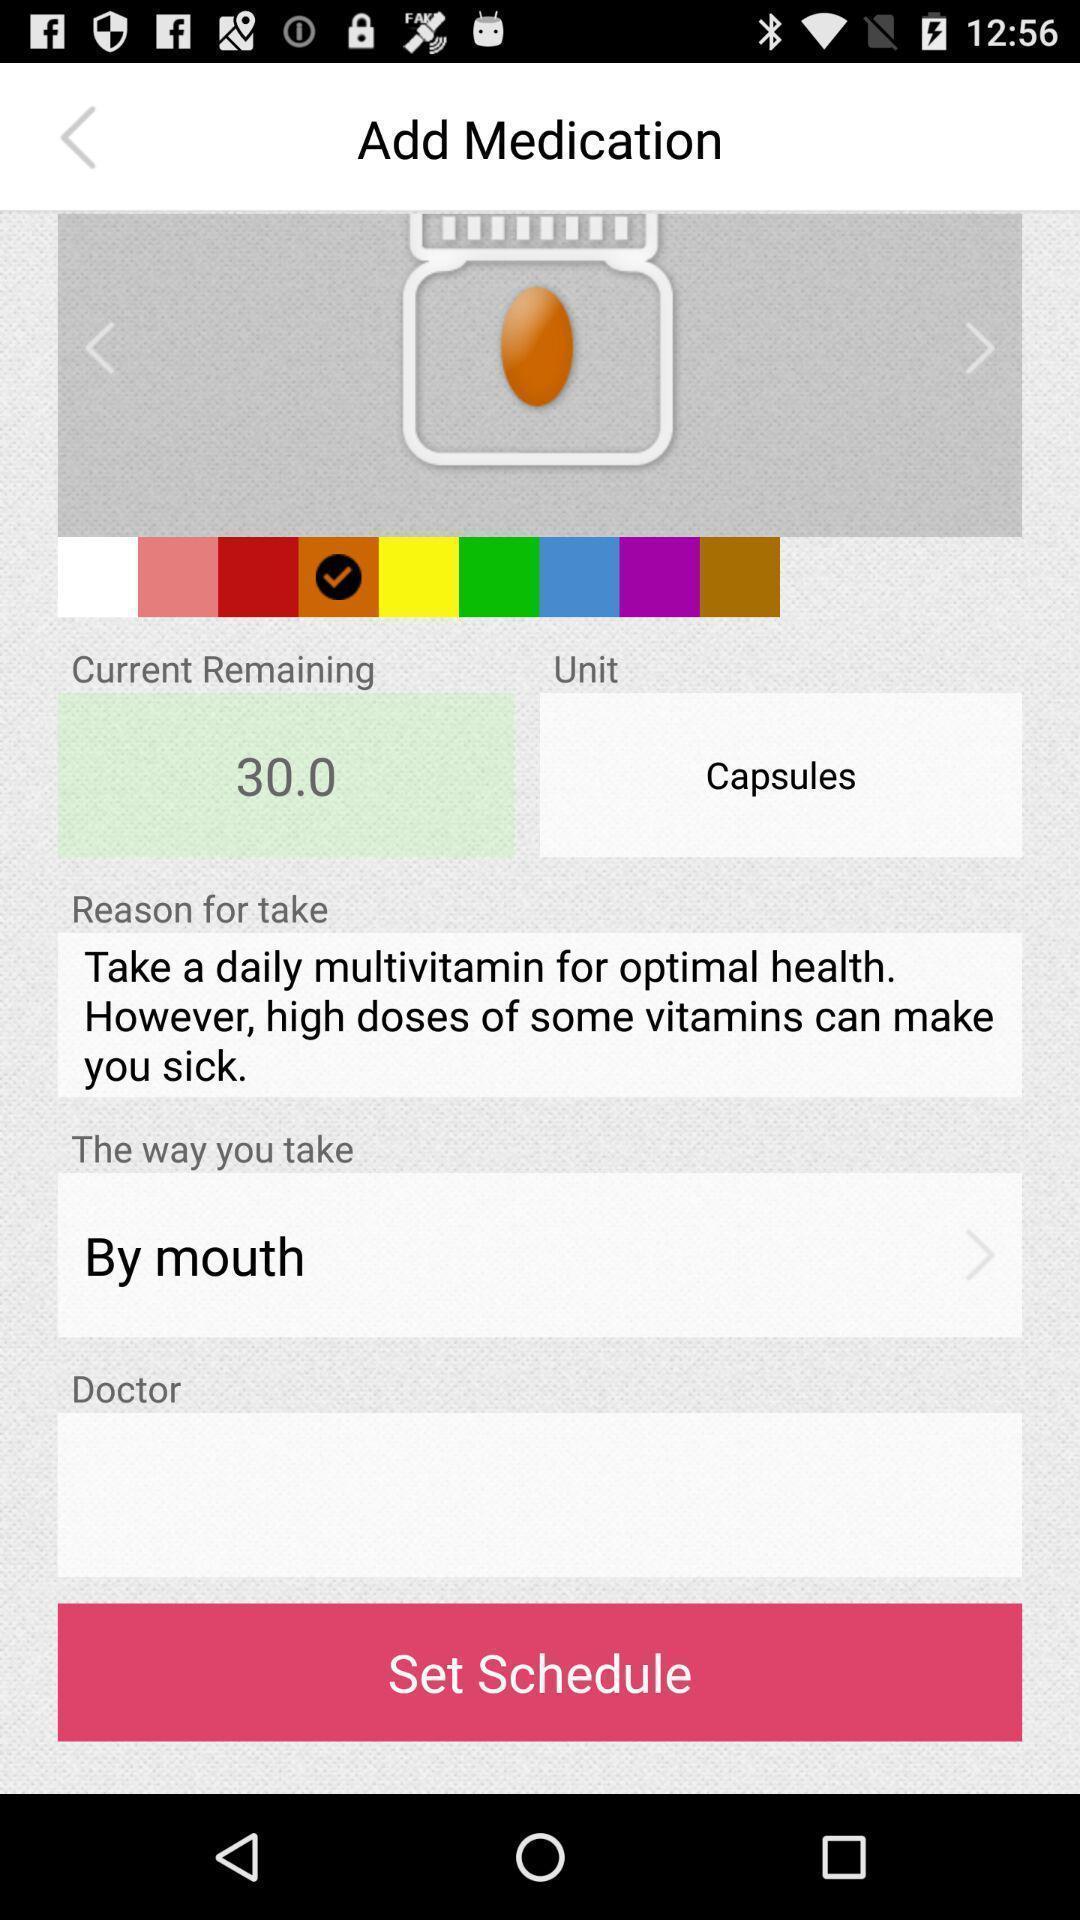Summarize the main components in this picture. Page to set medicine schedule in the medical app. 